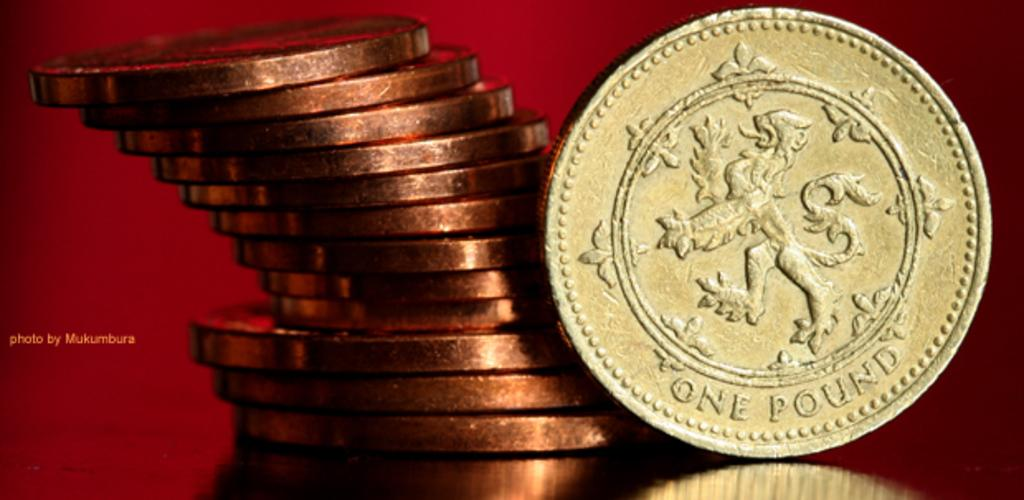<image>
Render a clear and concise summary of the photo. A stack of gold colored coins with one laying on its side that says One Pound. 